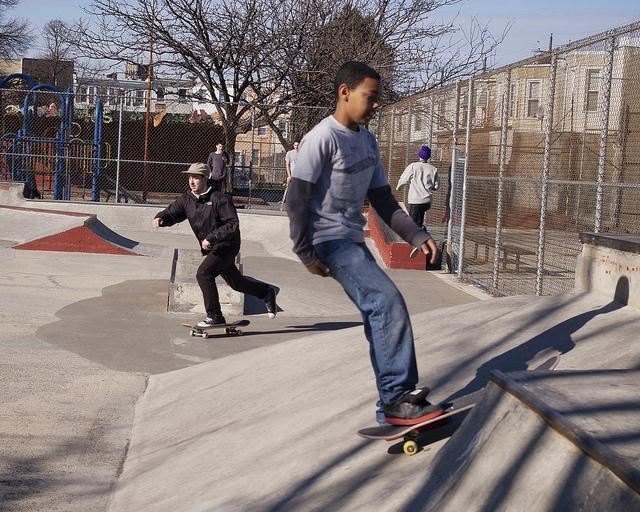How many people are in the picture?
Give a very brief answer. 2. How many trains are there?
Give a very brief answer. 0. 